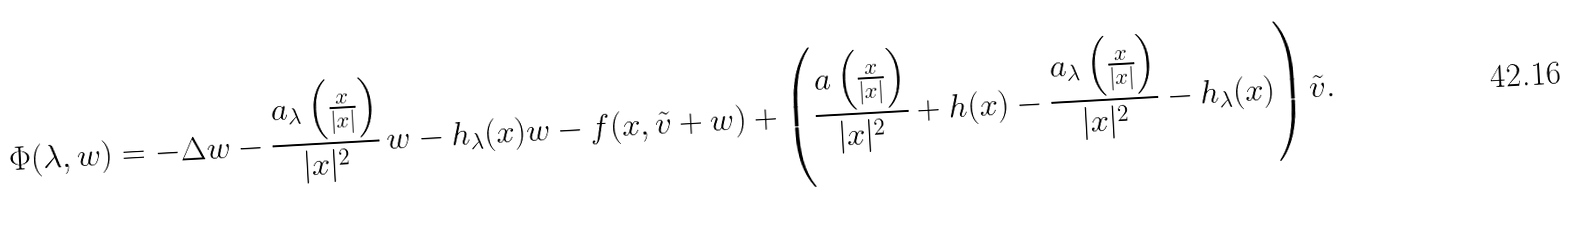Convert formula to latex. <formula><loc_0><loc_0><loc_500><loc_500>\Phi ( \lambda , w ) = - \Delta w - \frac { a _ { \lambda } \left ( \frac { x } { | x | } \right ) } { | x | ^ { 2 } } \, w - h _ { \lambda } ( x ) w - f ( x , \tilde { v } + w ) + \left ( \frac { a \left ( \frac { x } { | x | } \right ) } { | x | ^ { 2 } } + h ( x ) - \frac { a _ { \lambda } \left ( \frac { x } { | x | } \right ) } { | x | ^ { 2 } } - h _ { \lambda } ( x ) \right ) \tilde { v } .</formula> 